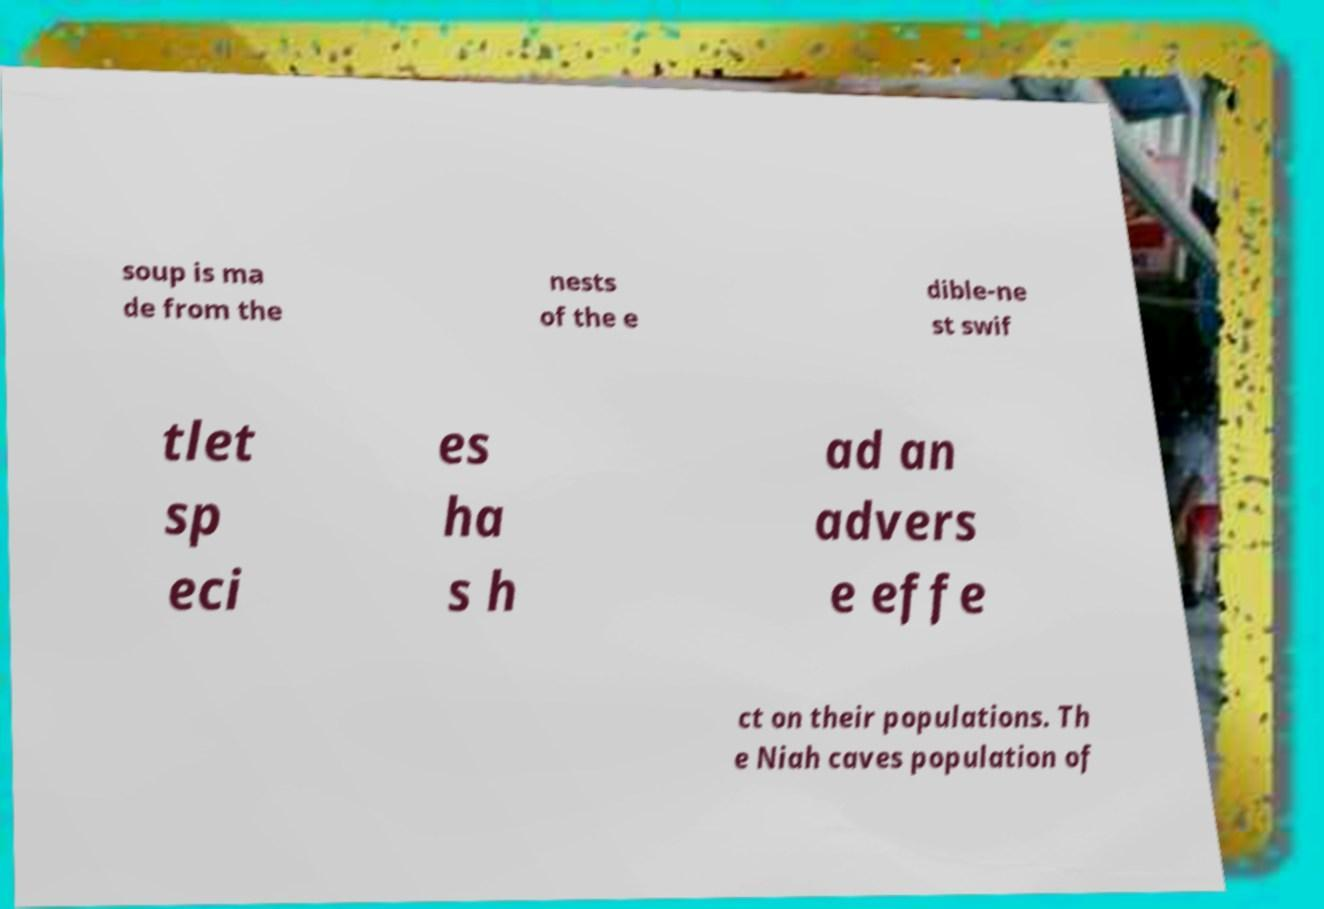For documentation purposes, I need the text within this image transcribed. Could you provide that? soup is ma de from the nests of the e dible-ne st swif tlet sp eci es ha s h ad an advers e effe ct on their populations. Th e Niah caves population of 